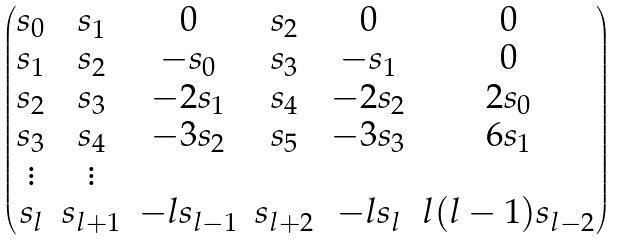Convert formula to latex. <formula><loc_0><loc_0><loc_500><loc_500>\begin{pmatrix} s _ { 0 } & s _ { 1 } & 0 & s _ { 2 } & 0 & 0 \\ s _ { 1 } & s _ { 2 } & - s _ { 0 } & s _ { 3 } & - s _ { 1 } & 0 \\ s _ { 2 } & s _ { 3 } & - 2 s _ { 1 } & s _ { 4 } & - 2 s _ { 2 } & 2 s _ { 0 } \\ s _ { 3 } & s _ { 4 } & - 3 s _ { 2 } & s _ { 5 } & - 3 s _ { 3 } & 6 s _ { 1 } \\ \vdots & \vdots \\ s _ { l } & s _ { l + 1 } & - l s _ { l - 1 } & s _ { l + 2 } & - l s _ { l } & l ( l - 1 ) s _ { l - 2 } \end{pmatrix}</formula> 